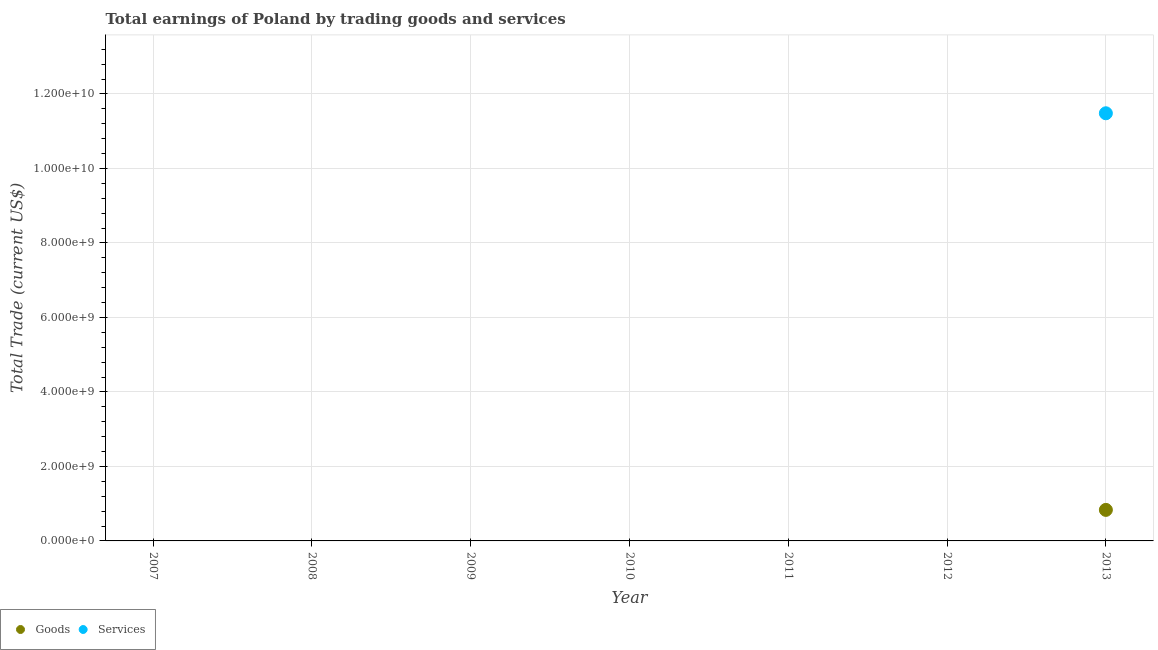How many different coloured dotlines are there?
Your answer should be compact. 2. Across all years, what is the maximum amount earned by trading services?
Provide a succinct answer. 1.15e+1. Across all years, what is the minimum amount earned by trading services?
Provide a succinct answer. 0. In which year was the amount earned by trading goods maximum?
Your answer should be very brief. 2013. What is the total amount earned by trading goods in the graph?
Offer a terse response. 8.33e+08. What is the average amount earned by trading services per year?
Provide a short and direct response. 1.64e+09. In the year 2013, what is the difference between the amount earned by trading services and amount earned by trading goods?
Keep it short and to the point. 1.06e+1. In how many years, is the amount earned by trading services greater than 4800000000 US$?
Offer a terse response. 1. What is the difference between the highest and the lowest amount earned by trading services?
Give a very brief answer. 1.15e+1. Is the amount earned by trading services strictly greater than the amount earned by trading goods over the years?
Offer a terse response. Yes. Is the amount earned by trading services strictly less than the amount earned by trading goods over the years?
Provide a short and direct response. No. How many dotlines are there?
Offer a terse response. 2. How many years are there in the graph?
Ensure brevity in your answer.  7. Does the graph contain any zero values?
Keep it short and to the point. Yes. Does the graph contain grids?
Provide a short and direct response. Yes. How many legend labels are there?
Offer a terse response. 2. How are the legend labels stacked?
Give a very brief answer. Horizontal. What is the title of the graph?
Offer a very short reply. Total earnings of Poland by trading goods and services. Does "Urban agglomerations" appear as one of the legend labels in the graph?
Keep it short and to the point. No. What is the label or title of the Y-axis?
Offer a terse response. Total Trade (current US$). What is the Total Trade (current US$) of Goods in 2007?
Make the answer very short. 0. What is the Total Trade (current US$) of Services in 2007?
Offer a very short reply. 0. What is the Total Trade (current US$) of Services in 2008?
Keep it short and to the point. 0. What is the Total Trade (current US$) of Services in 2009?
Provide a short and direct response. 0. What is the Total Trade (current US$) of Services in 2010?
Offer a very short reply. 0. What is the Total Trade (current US$) of Services in 2011?
Offer a very short reply. 0. What is the Total Trade (current US$) of Services in 2012?
Your response must be concise. 0. What is the Total Trade (current US$) of Goods in 2013?
Your answer should be compact. 8.33e+08. What is the Total Trade (current US$) in Services in 2013?
Offer a terse response. 1.15e+1. Across all years, what is the maximum Total Trade (current US$) in Goods?
Give a very brief answer. 8.33e+08. Across all years, what is the maximum Total Trade (current US$) of Services?
Your response must be concise. 1.15e+1. What is the total Total Trade (current US$) in Goods in the graph?
Your response must be concise. 8.33e+08. What is the total Total Trade (current US$) in Services in the graph?
Provide a short and direct response. 1.15e+1. What is the average Total Trade (current US$) in Goods per year?
Ensure brevity in your answer.  1.19e+08. What is the average Total Trade (current US$) of Services per year?
Your answer should be very brief. 1.64e+09. In the year 2013, what is the difference between the Total Trade (current US$) in Goods and Total Trade (current US$) in Services?
Provide a succinct answer. -1.06e+1. What is the difference between the highest and the lowest Total Trade (current US$) in Goods?
Ensure brevity in your answer.  8.33e+08. What is the difference between the highest and the lowest Total Trade (current US$) in Services?
Offer a very short reply. 1.15e+1. 